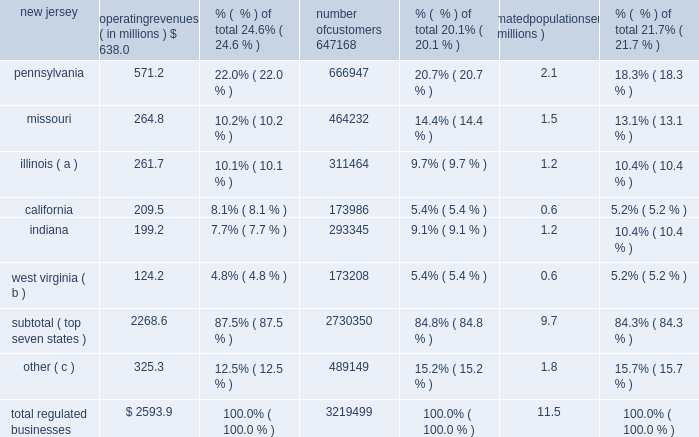Acquisition added approximately 1700 water customers and nearly 2000 wastewater customers .
The tex as assets served approximately 4200 water and 1100 wastewater customers in the greater houston metropolitan as noted above , as a result of these sales , these regulated subsidiaries are presented as discontinued operations for all periods presented .
Therefore , the amounts , statistics and tables presented in this section refer only to on-going operations , unless otherwise noted .
The table sets forth our regulated businesses operating revenue for 2013 and number of customers from continuing operations as well as an estimate of population served as of december 31 , 2013 : operating revenues ( in millions ) % (  % ) of total number of customers % (  % ) of total estimated population served ( in millions ) % (  % ) of total .
( a ) includes illinois-american water company , which we refer to as ilawc and american lake water company , also a regulated subsidiary in illinois .
( b ) west virginia-american water company , which we refer to as wvawc , and its subsidiary bluefield valley water works company .
( c ) includes data from our operating subsidiaries in the following states : georgia , hawaii , iowa , kentucky , maryland , michigan , new york , tennessee , and virginia .
Approximately 87.5 % (  % ) of operating revenue from our regulated businesses in 2013 was generated from approximately 2.7 million customers in our seven largest states , as measured by operating revenues .
In fiscal year 2013 , no single customer accounted for more than 10% ( 10 % ) of our annual operating revenue .
Overview of networks , facilities and water supply our regulated businesses operate in approximately 1500 communities in 16 states in the united states .
Our primary operating assets include 87 dams along with approximately 80 surface water treatment plants , 500 groundwater treatment plants , 1000 groundwater wells , 100 wastewater treatment facilities , 1200 treated water storage facilities , 1300 pumping stations , and 47000 miles of mains and collection pipes .
Our regulated utilities own substantially all of the assets used by our regulated businesses .
We generally own the land and physical assets used to store , extract and treat source water .
Typically , we do not own the water itself , which is held in public trust and is allocated to us through contracts and allocation rights granted by federal and state agencies or through the ownership of water rights pursuant to local law .
Maintaining the reliability of our networks is a key activity of our regulated businesses .
We have ongoing infrastructure renewal programs in all states in which our regulated businesses operate .
These programs consist of both rehabilitation of existing mains and replacement of mains that have reached the end of their useful service lives .
Our ability to meet the existing and future water demands of our customers depends on an adequate supply of water .
Drought , governmental restrictions , overuse of sources of water , the protection of threatened species or .
What is the average annual revenue per customer in california? 
Computations: (209.5 * 1000000)
Answer: 209500000.0. 